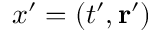<formula> <loc_0><loc_0><loc_500><loc_500>x ^ { \prime } = ( t ^ { \prime } , r ^ { \prime } )</formula> 